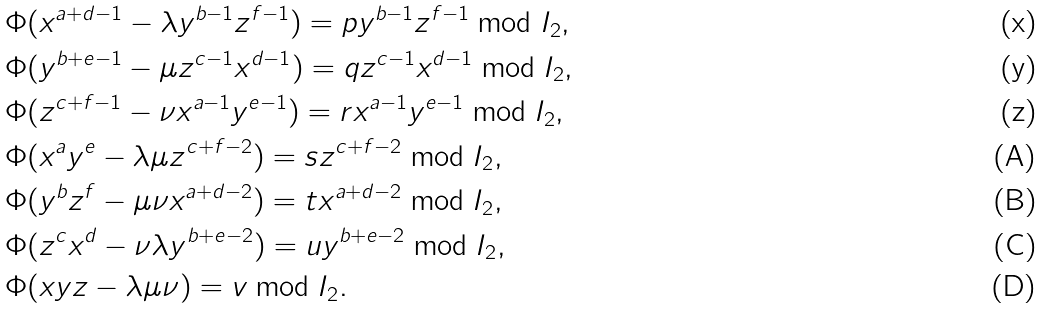Convert formula to latex. <formula><loc_0><loc_0><loc_500><loc_500>& \Phi ( x ^ { a + d - 1 } - \lambda y ^ { b - 1 } z ^ { f - 1 } ) = p y ^ { b - 1 } z ^ { f - 1 } \bmod I _ { 2 } , \\ & \Phi ( y ^ { b + e - 1 } - \mu z ^ { c - 1 } x ^ { d - 1 } ) = q z ^ { c - 1 } x ^ { d - 1 } \bmod I _ { 2 } , \\ & \Phi ( z ^ { c + f - 1 } - \nu x ^ { a - 1 } y ^ { e - 1 } ) = r x ^ { a - 1 } y ^ { e - 1 } \bmod I _ { 2 } , \\ & \Phi ( x ^ { a } y ^ { e } - \lambda \mu z ^ { c + f - 2 } ) = s z ^ { c + f - 2 } \bmod I _ { 2 } , \\ & \Phi ( y ^ { b } z ^ { f } - \mu \nu x ^ { a + d - 2 } ) = t x ^ { a + d - 2 } \bmod I _ { 2 } , \\ & \Phi ( z ^ { c } x ^ { d } - \nu \lambda y ^ { b + e - 2 } ) = u y ^ { b + e - 2 } \bmod I _ { 2 } , \\ & \Phi ( x y z - \lambda \mu \nu ) = v \bmod I _ { 2 } .</formula> 